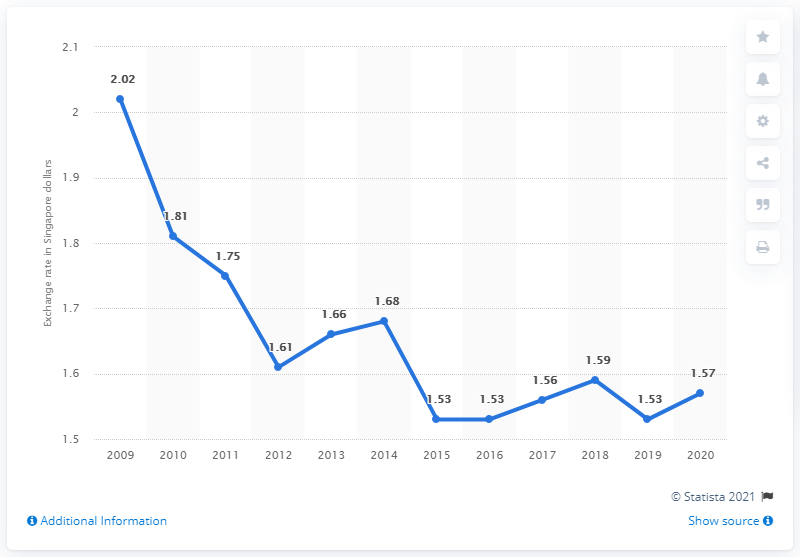Identify some key points in this picture. The average exchange rate from Singapore dollars to Euros in 2020 was 1.57. In 2020, the average exchange rate from Singapore dollars to Euros was 1.57. 